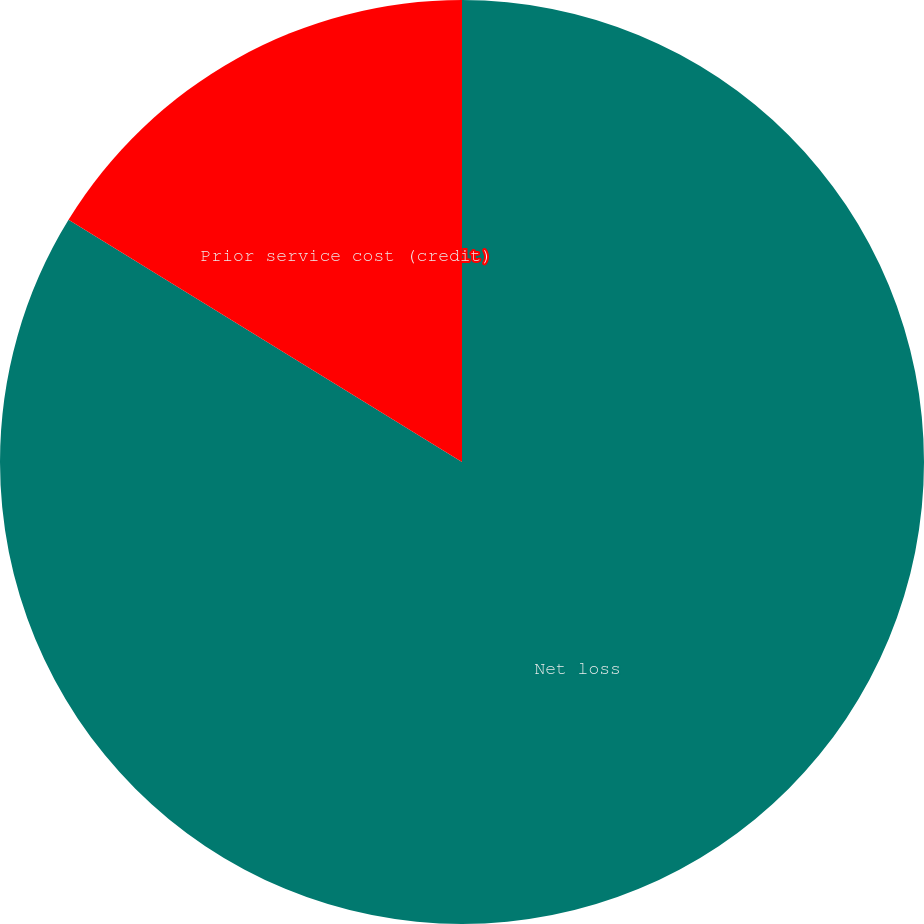<chart> <loc_0><loc_0><loc_500><loc_500><pie_chart><fcel>Net loss<fcel>Prior service cost (credit)<nl><fcel>83.78%<fcel>16.22%<nl></chart> 